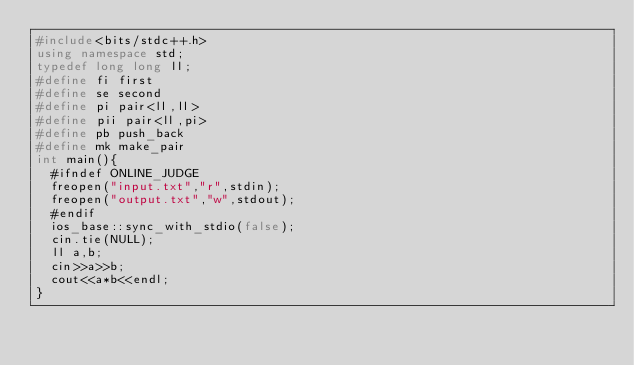<code> <loc_0><loc_0><loc_500><loc_500><_C++_>#include<bits/stdc++.h>
using namespace std;
typedef long long ll;
#define fi first 
#define se second
#define pi pair<ll,ll> 
#define pii pair<ll,pi>
#define pb push_back
#define mk make_pair
int main(){ 
  #ifndef ONLINE_JUDGE
	freopen("input.txt","r",stdin);
	freopen("output.txt","w",stdout);
  #endif
  ios_base::sync_with_stdio(false);
  cin.tie(NULL);
  ll a,b;
  cin>>a>>b;
  cout<<a*b<<endl;
}</code> 